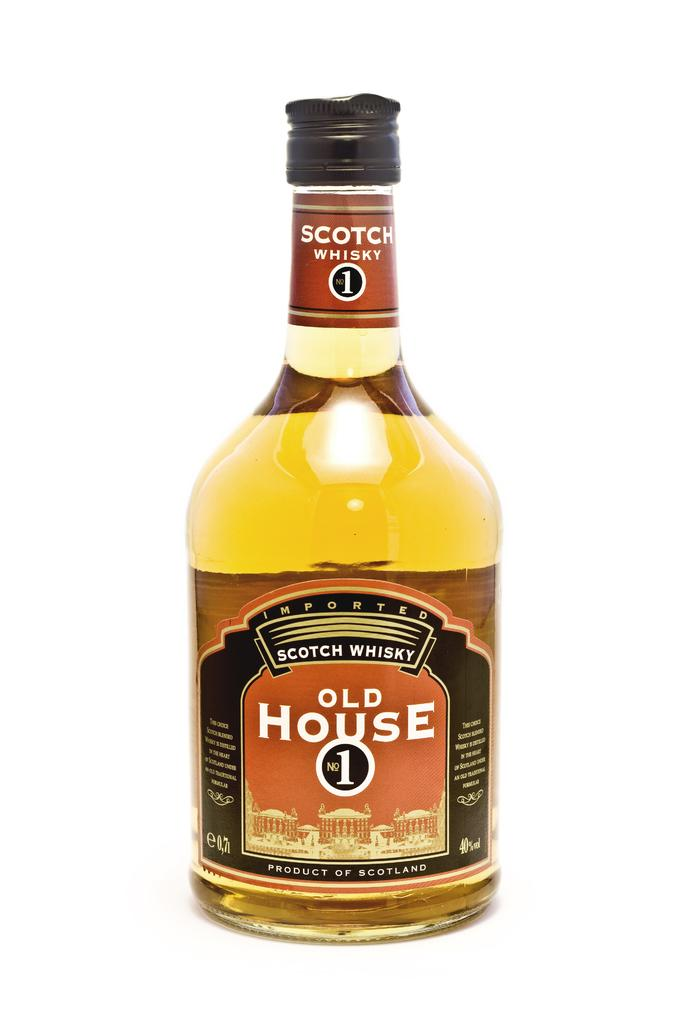Provide a one-sentence caption for the provided image. A simple picture of a full bottle of Old House No.1 whisky. 